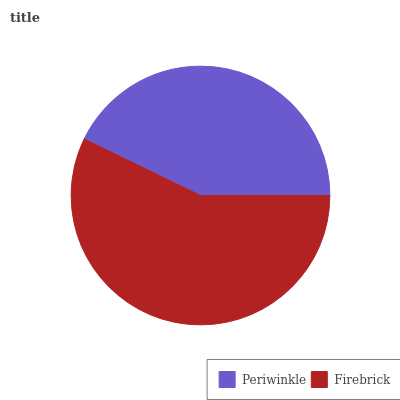Is Periwinkle the minimum?
Answer yes or no. Yes. Is Firebrick the maximum?
Answer yes or no. Yes. Is Firebrick the minimum?
Answer yes or no. No. Is Firebrick greater than Periwinkle?
Answer yes or no. Yes. Is Periwinkle less than Firebrick?
Answer yes or no. Yes. Is Periwinkle greater than Firebrick?
Answer yes or no. No. Is Firebrick less than Periwinkle?
Answer yes or no. No. Is Firebrick the high median?
Answer yes or no. Yes. Is Periwinkle the low median?
Answer yes or no. Yes. Is Periwinkle the high median?
Answer yes or no. No. Is Firebrick the low median?
Answer yes or no. No. 